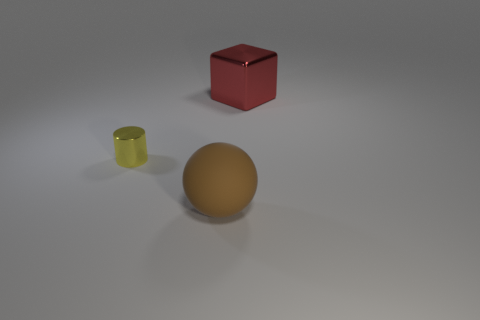What color is the matte ball that is the same size as the red shiny thing?
Provide a succinct answer. Brown. Are there any big red cubes made of the same material as the small yellow cylinder?
Your answer should be compact. Yes. Are there fewer big things that are in front of the rubber sphere than tiny red rubber cylinders?
Give a very brief answer. No. Does the metal thing that is in front of the red metal thing have the same size as the large red shiny cube?
Offer a terse response. No. What number of tiny yellow things have the same shape as the red object?
Keep it short and to the point. 0. What is the size of the red block that is made of the same material as the yellow cylinder?
Give a very brief answer. Large. Are there the same number of tiny yellow metal cylinders behind the yellow thing and brown metallic things?
Provide a short and direct response. Yes. What color is the thing that is both behind the brown thing and in front of the large metallic thing?
Keep it short and to the point. Yellow. There is a big object behind the large thing on the left side of the big cube; is there a big shiny block in front of it?
Give a very brief answer. No. What number of things are either small cyan matte balls or big objects?
Offer a terse response. 2. 